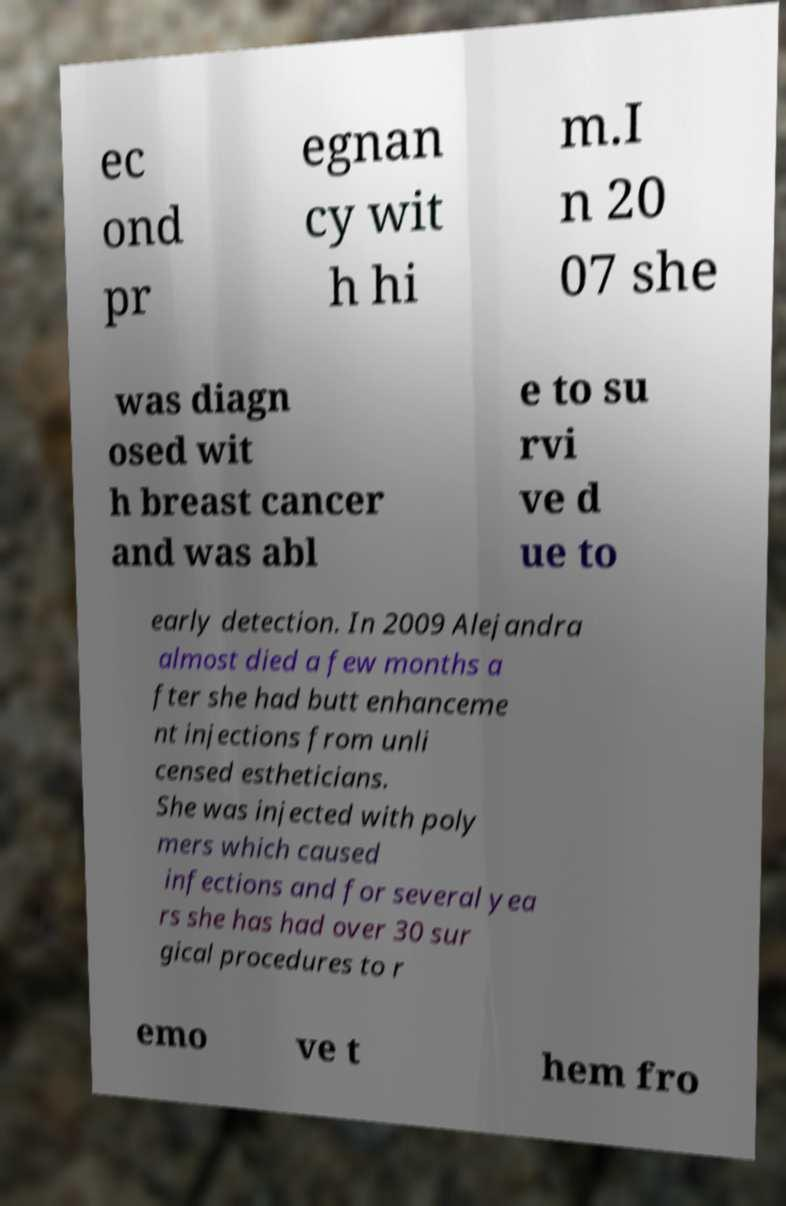Can you accurately transcribe the text from the provided image for me? ec ond pr egnan cy wit h hi m.I n 20 07 she was diagn osed wit h breast cancer and was abl e to su rvi ve d ue to early detection. In 2009 Alejandra almost died a few months a fter she had butt enhanceme nt injections from unli censed estheticians. She was injected with poly mers which caused infections and for several yea rs she has had over 30 sur gical procedures to r emo ve t hem fro 